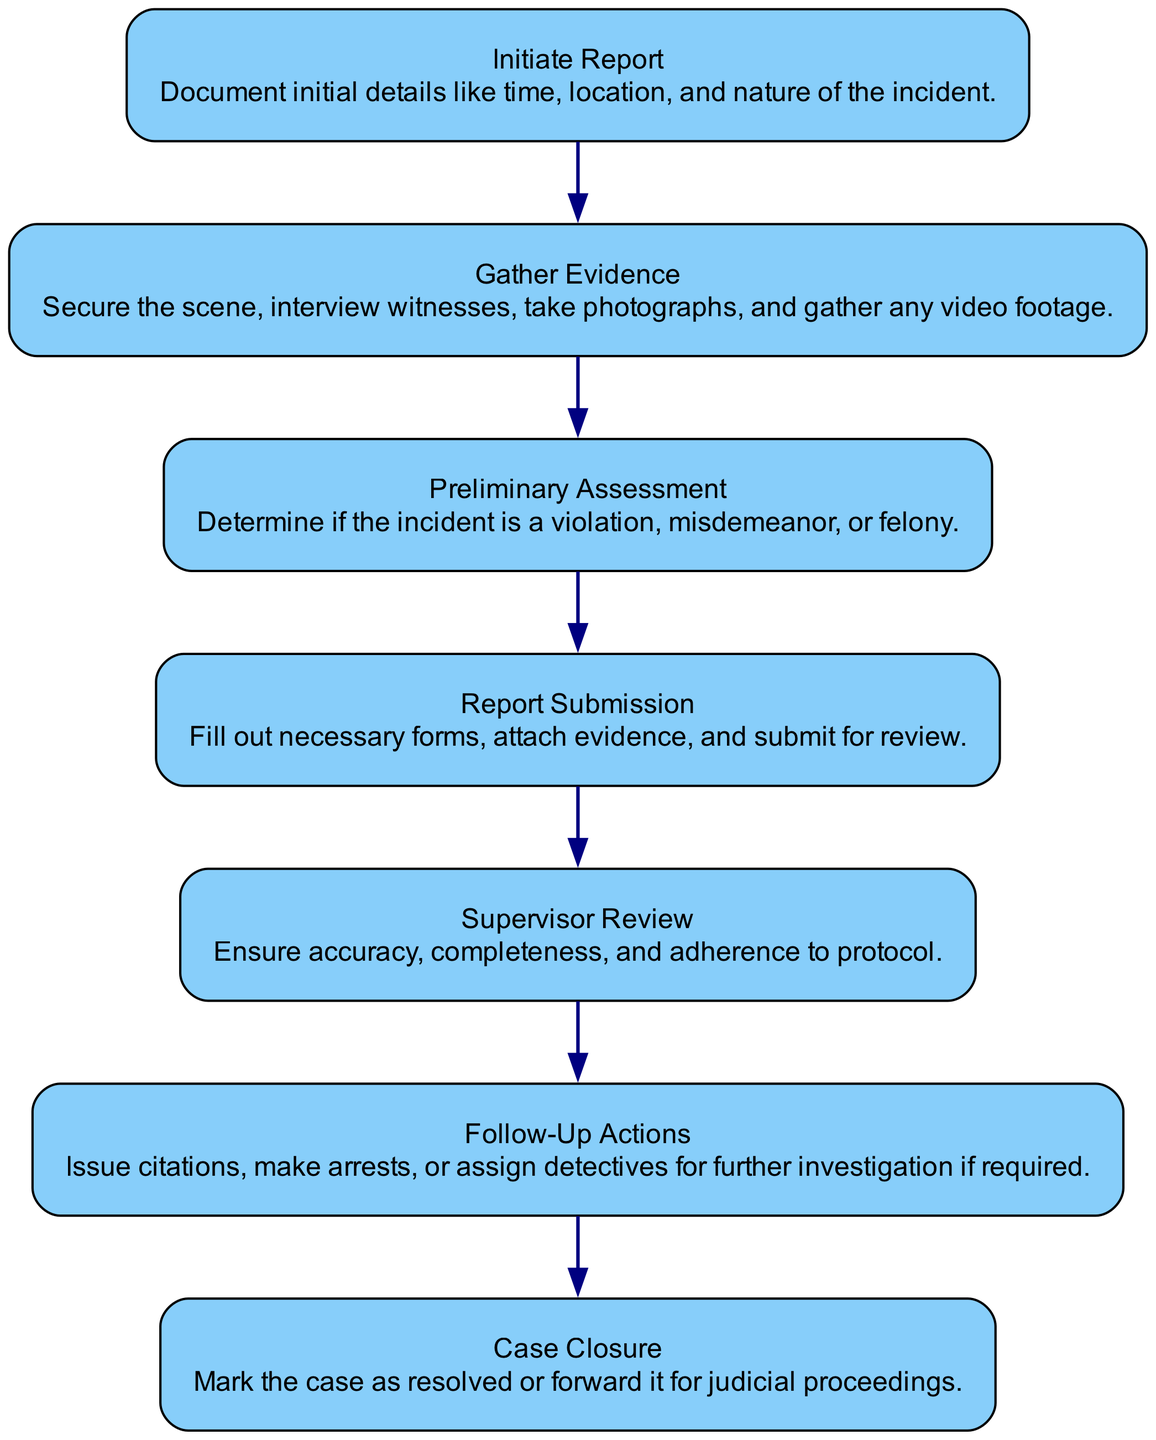What is the first step in the diagram? The first step is "Initiate Report," as indicated by its position at the top of the flowchart. It serves as the starting point where the officer observes an incident or receives a report from a citizen.
Answer: Initiate Report How many total steps are there in the process? By counting all the distinct elements or nodes in the flowchart, there are seven steps listed from "Initiate Report" to "Case Closure."
Answer: Seven What is the action associated with "Gather Evidence"? The action tied to "Gather Evidence" is explained as collecting physical and digital evidence from the incident scene, including securing the scene, interviewing witnesses, and gathering video footage.
Answer: Collect evidence What relationship exists between "Supervisor Review" and "Follow-Up Actions"? The relationship is that "Follow-Up Actions" occurs after "Supervisor Review." The diagram indicates a sequential flow from the supervisor's review of the report to the required follow-up tasks based on the feedback received.
Answer: Sequential flow What type of assessment occurs after gathering evidence? The type of assessment that follows gathering evidence is called "Preliminary Assessment," where collected evidence is evaluated, and the incident is categorized.
Answer: Preliminary Assessment Which step directly leads to case closure? The step that leads directly to case closure is "Follow-Up Actions," as it entails performing necessary tasks based on feedback that can include actions leading to closure.
Answer: Follow-Up Actions What does the action for "Report Submission" include? The action includes filing the detailed incident report, which consists of filling out forms, attaching evidence, and submitting it for review.
Answer: Fill out forms What step must occur before report submission? "Preliminary Assessment" must occur before report submission, as it involves evaluating evidence and categorizing the situation prior to the final report filing.
Answer: Preliminary Assessment What is the final action in the flowchart? The final action presented in the flowchart is "Case Closure," marking the completion of the reporting and follow-up process, resolving the incident or forwarding it to judicial proceedings.
Answer: Case Closure 